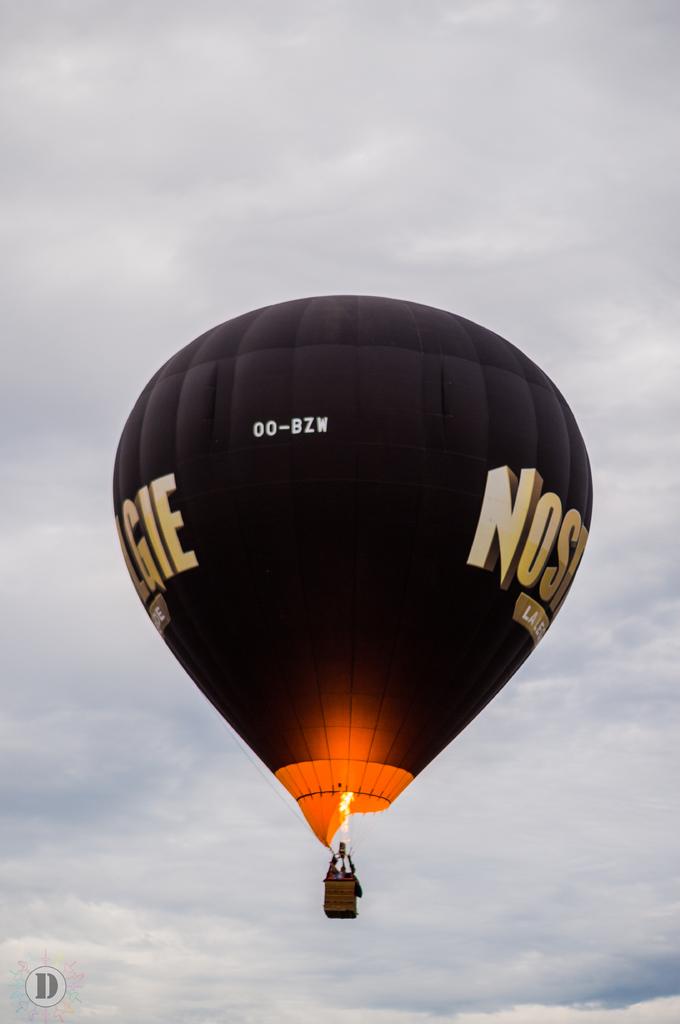What is the identification number on the balloon?
Make the answer very short. 00-bzw. What is the last letter on the balloon?
Your answer should be compact. E. 